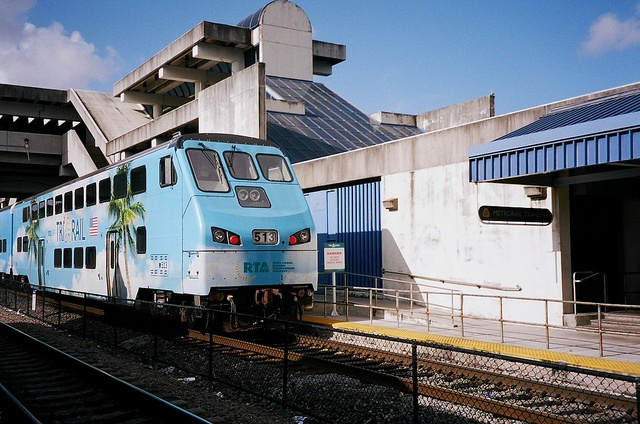Describe the objects in this image and their specific colors. I can see a train in gray, black, lightblue, lightgray, and darkgray tones in this image. 